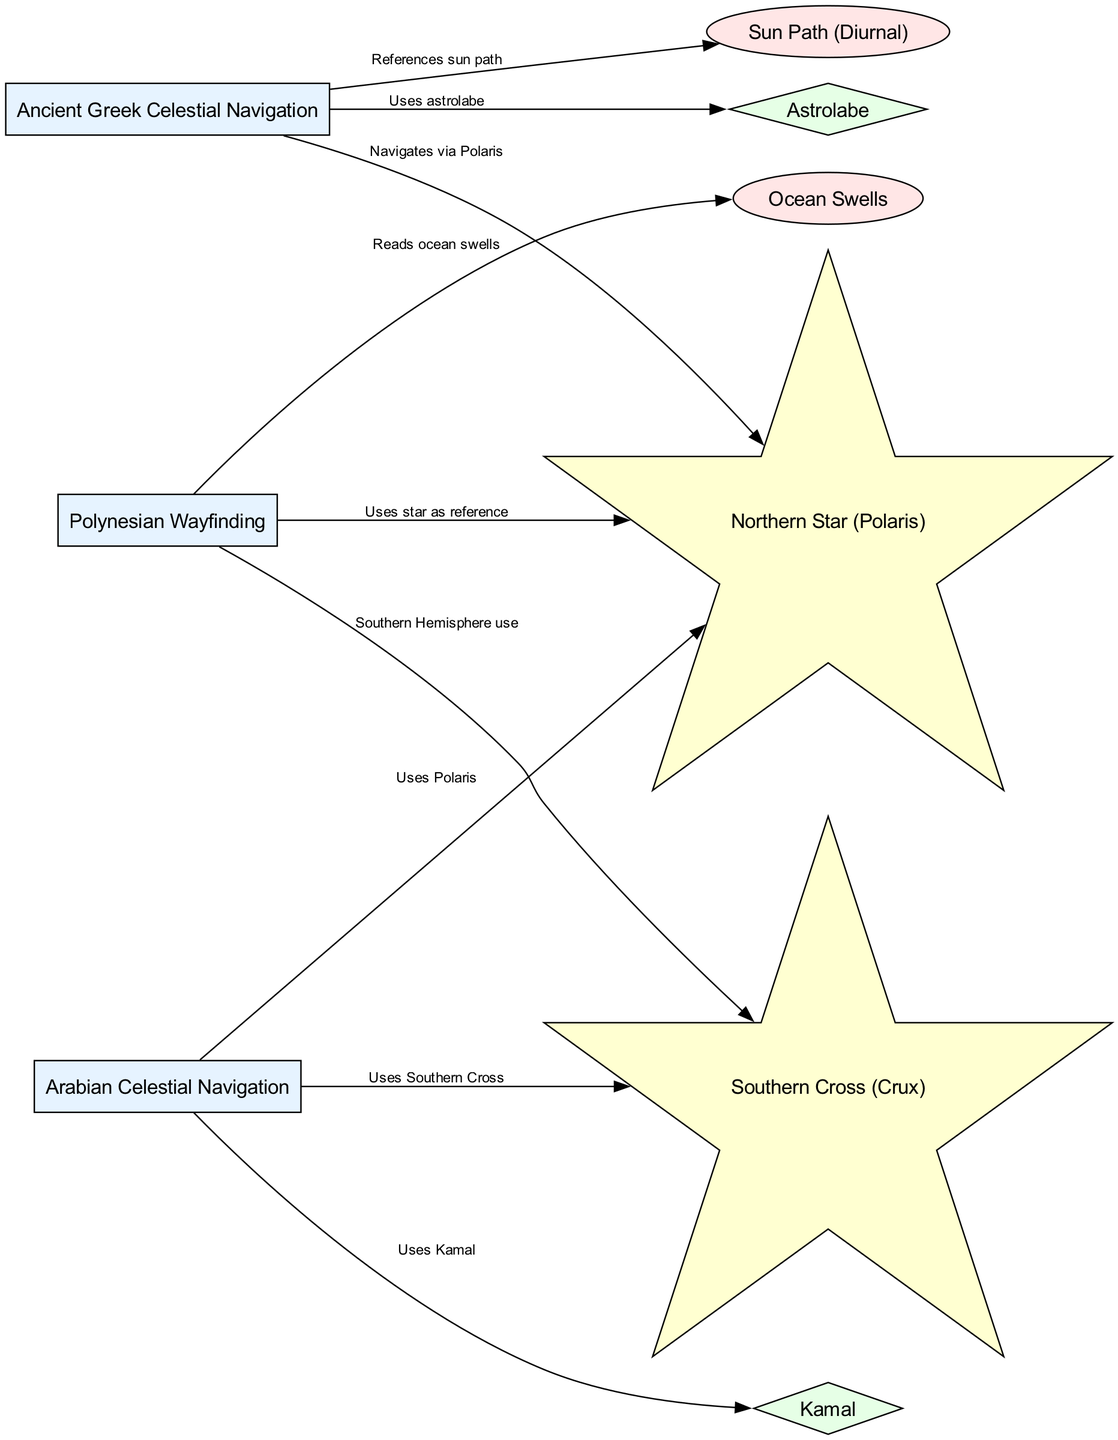What are the two celestial navigation methods mentioned for the Arabian culture? The diagram shows that Arabian Celestial Navigation uses Polaris and the Southern Cross, as indicated by the edges connecting these nodes.
Answer: Polaris, Southern Cross How many methods of celestial navigation are depicted in the diagram? Counting the nodes representing methods, there are three methods: Polynesian Wayfinding, Ancient Greek Celestial Navigation, and Arabian Celestial Navigation.
Answer: 3 Which instrument is used by Ancient Greek Celestial Navigation? The diagram indicates that the Ancient Greek Celestial Navigation method is connected to the Astrolabe, confirming its use as an instrument.
Answer: Astrolabe What external cue does Polynesian Wayfinding utilize? The diagram connects Polynesian Wayfinding to Ocean Swells, indicating that this external cue is utilized in its navigation method.
Answer: Ocean Swells Which star is used by both Arabian and Ancient Greek Celestial Navigation? Both Arabian Celestial Navigation and Ancient Greek Celestial Navigation are connected to the Polaris node, indicating that they use this star for navigation.
Answer: Polaris What external cue does Ancient Greek Celestial Navigation reference? The diagram shows the connection from Ancient Greek Celestial Navigation to the Sun Path, indicating that this external cue is referenced in the navigation process.
Answer: Sun Path What is the connection between Polynesian Wayfinding and the Southern Cross? The diagram illustrates a connection from Polynesian Wayfinding to the Southern Cross, showing that this star is referenced particularly for navigation in the Southern Hemisphere.
Answer: Southern Hemisphere use Which instrument is used in Arabian Celestial Navigation? The diagram indicates that Arabian Celestial Navigation is connected to the Kamal, highlighting its use as a navigational instrument.
Answer: Kamal What is the total number of edges in the diagram? By counting the connections of the edges listed in the data, there are eight edges depicting relationships between the methods, stars, external cues, and instruments.
Answer: 8 